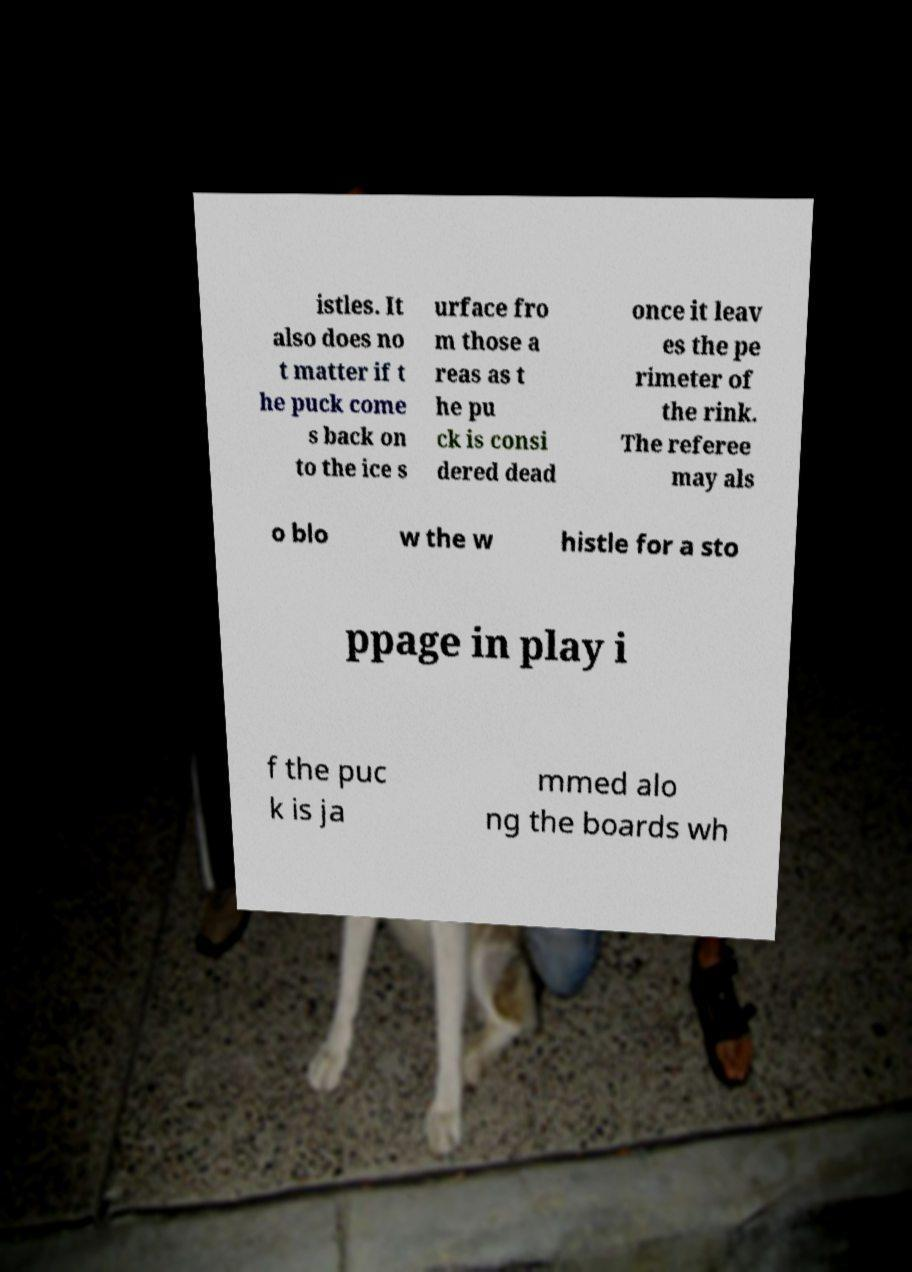There's text embedded in this image that I need extracted. Can you transcribe it verbatim? istles. It also does no t matter if t he puck come s back on to the ice s urface fro m those a reas as t he pu ck is consi dered dead once it leav es the pe rimeter of the rink. The referee may als o blo w the w histle for a sto ppage in play i f the puc k is ja mmed alo ng the boards wh 